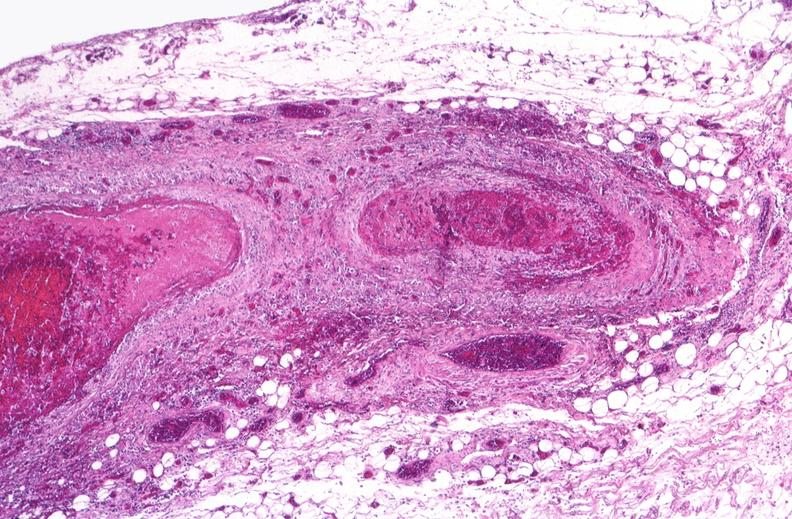s retroperitoneum present?
Answer the question using a single word or phrase. No 